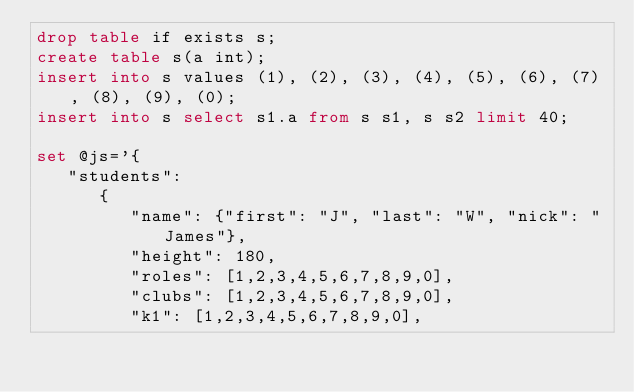Convert code to text. <code><loc_0><loc_0><loc_500><loc_500><_SQL_>drop table if exists s;
create table s(a int);
insert into s values (1), (2), (3), (4), (5), (6), (7), (8), (9), (0);
insert into s select s1.a from s s1, s s2 limit 40;

set @js='{
   "students":
      {
         "name": {"first": "J", "last": "W", "nick": "James"},
         "height": 180,
         "roles": [1,2,3,4,5,6,7,8,9,0],
         "clubs": [1,2,3,4,5,6,7,8,9,0],
         "k1": [1,2,3,4,5,6,7,8,9,0],</code> 